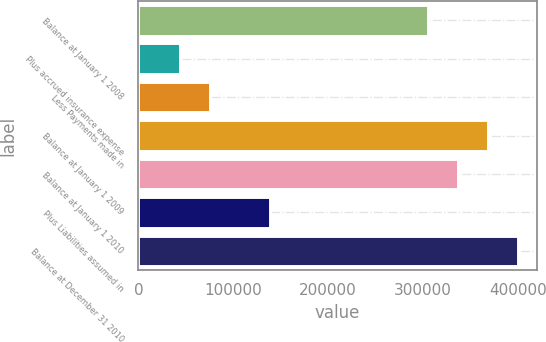Convert chart. <chart><loc_0><loc_0><loc_500><loc_500><bar_chart><fcel>Balance at January 1 2008<fcel>Plus accrued insurance expense<fcel>Less Payments made in<fcel>Balance at January 1 2009<fcel>Balance at January 1 2010<fcel>Plus Liabilities assumed in<fcel>Balance at December 31 2010<nl><fcel>304755<fcel>44314<fcel>75928.7<fcel>367984<fcel>336370<fcel>139158<fcel>399599<nl></chart> 